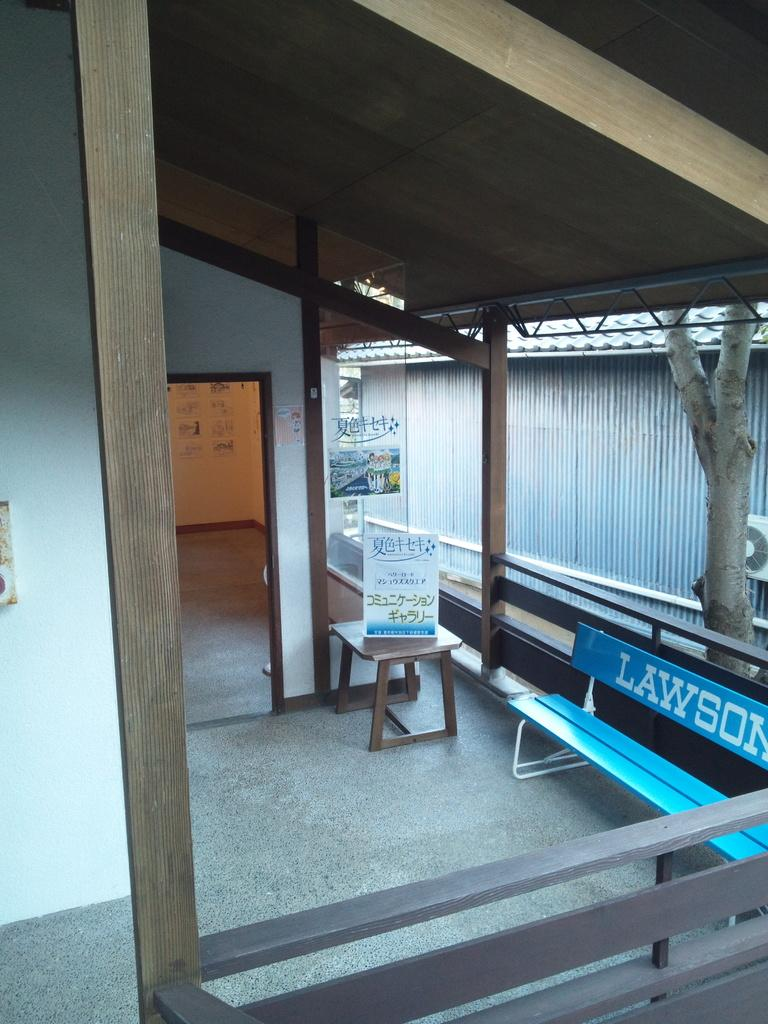Provide a one-sentence caption for the provided image. blue bench with the words lawson on its back rest. 